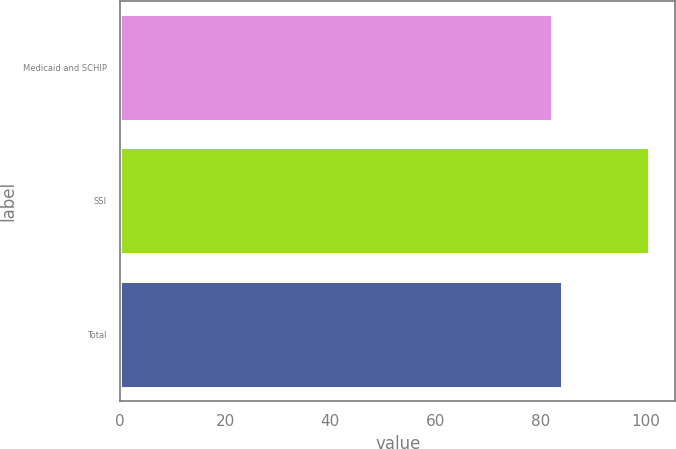Convert chart. <chart><loc_0><loc_0><loc_500><loc_500><bar_chart><fcel>Medicaid and SCHIP<fcel>SSI<fcel>Total<nl><fcel>82.2<fcel>100.7<fcel>84.05<nl></chart> 